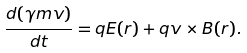Convert formula to latex. <formula><loc_0><loc_0><loc_500><loc_500>\frac { d ( \gamma m v ) } { d t } = q E ( r ) + q v \times B ( r ) .</formula> 